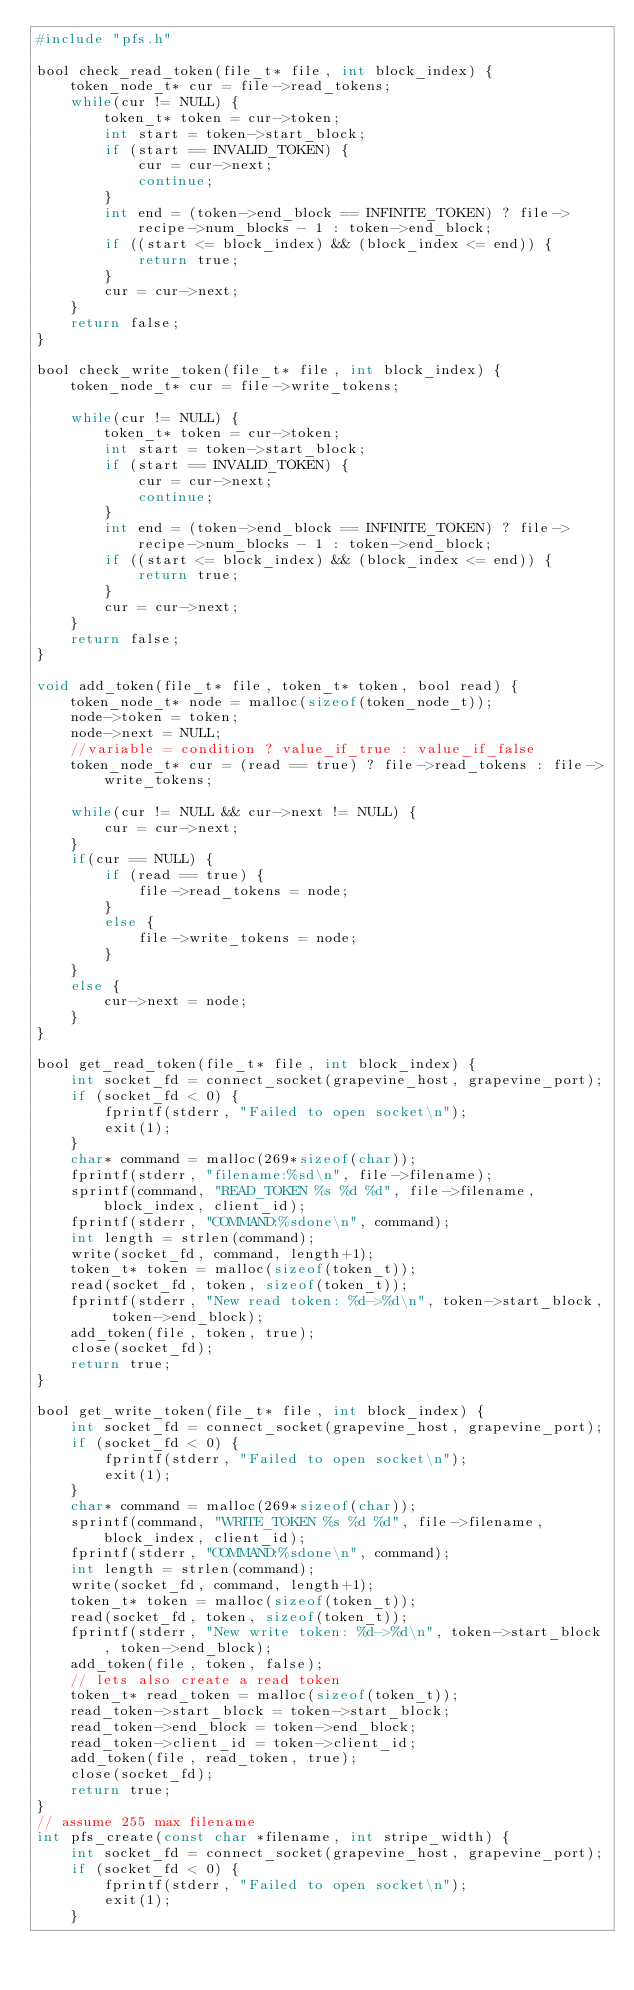<code> <loc_0><loc_0><loc_500><loc_500><_C_>#include "pfs.h"

bool check_read_token(file_t* file, int block_index) {
    token_node_t* cur = file->read_tokens;
    while(cur != NULL) {
        token_t* token = cur->token;
        int start = token->start_block;
        if (start == INVALID_TOKEN) {
            cur = cur->next;
            continue;
        }
        int end = (token->end_block == INFINITE_TOKEN) ? file->recipe->num_blocks - 1 : token->end_block;       
        if ((start <= block_index) && (block_index <= end)) {
            return true;
        }
        cur = cur->next;
    }
    return false;
}

bool check_write_token(file_t* file, int block_index) {
    token_node_t* cur = file->write_tokens;

    while(cur != NULL) {
        token_t* token = cur->token;
        int start = token->start_block;
        if (start == INVALID_TOKEN) {
            cur = cur->next;
            continue;
        }
        int end = (token->end_block == INFINITE_TOKEN) ? file->recipe->num_blocks - 1 : token->end_block;       
        if ((start <= block_index) && (block_index <= end)) {
            return true;
        }
        cur = cur->next;
    }
    return false;
}

void add_token(file_t* file, token_t* token, bool read) {
    token_node_t* node = malloc(sizeof(token_node_t));
    node->token = token;
    node->next = NULL;
    //variable = condition ? value_if_true : value_if_false
    token_node_t* cur = (read == true) ? file->read_tokens : file->write_tokens;

    while(cur != NULL && cur->next != NULL) {
        cur = cur->next;
    }
    if(cur == NULL) {
        if (read == true) {
            file->read_tokens = node;
        }
        else {
            file->write_tokens = node;
        }
    }
    else {
        cur->next = node;
    }
}

bool get_read_token(file_t* file, int block_index) {
    int socket_fd = connect_socket(grapevine_host, grapevine_port);
    if (socket_fd < 0) {
        fprintf(stderr, "Failed to open socket\n");
        exit(1);
    }
    char* command = malloc(269*sizeof(char));
    fprintf(stderr, "filename:%sd\n", file->filename);
    sprintf(command, "READ_TOKEN %s %d %d", file->filename, block_index, client_id);
    fprintf(stderr, "COMMAND:%sdone\n", command);
    int length = strlen(command);
    write(socket_fd, command, length+1);
    token_t* token = malloc(sizeof(token_t));
    read(socket_fd, token, sizeof(token_t));
    fprintf(stderr, "New read token: %d->%d\n", token->start_block, token->end_block);
    add_token(file, token, true);
    close(socket_fd);
    return true;
}

bool get_write_token(file_t* file, int block_index) {
    int socket_fd = connect_socket(grapevine_host, grapevine_port);
    if (socket_fd < 0) {
        fprintf(stderr, "Failed to open socket\n");
        exit(1);
    }
    char* command = malloc(269*sizeof(char));
    sprintf(command, "WRITE_TOKEN %s %d %d", file->filename, block_index, client_id);
    fprintf(stderr, "COMMAND:%sdone\n", command);
    int length = strlen(command);
    write(socket_fd, command, length+1);
    token_t* token = malloc(sizeof(token_t));
    read(socket_fd, token, sizeof(token_t));
    fprintf(stderr, "New write token: %d->%d\n", token->start_block, token->end_block);
    add_token(file, token, false);
    // lets also create a read token
    token_t* read_token = malloc(sizeof(token_t));
    read_token->start_block = token->start_block;
    read_token->end_block = token->end_block;
    read_token->client_id = token->client_id;
    add_token(file, read_token, true);
    close(socket_fd);
    return true;
}
// assume 255 max filename
int pfs_create(const char *filename, int stripe_width) {
    int socket_fd = connect_socket(grapevine_host, grapevine_port);
    if (socket_fd < 0) {
        fprintf(stderr, "Failed to open socket\n");
        exit(1);
    }</code> 